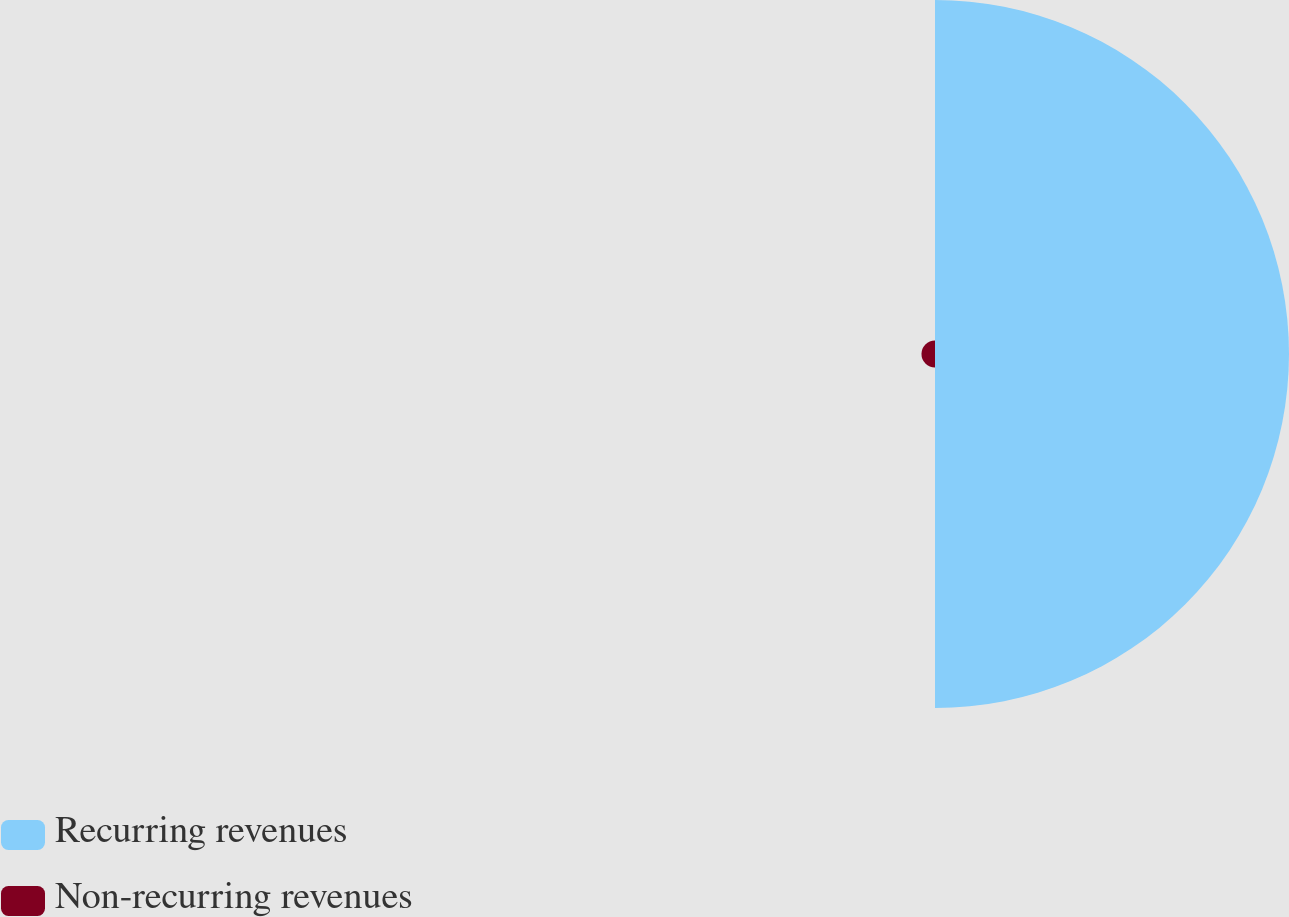Convert chart. <chart><loc_0><loc_0><loc_500><loc_500><pie_chart><fcel>Recurring revenues<fcel>Non-recurring revenues<nl><fcel>96.32%<fcel>3.68%<nl></chart> 